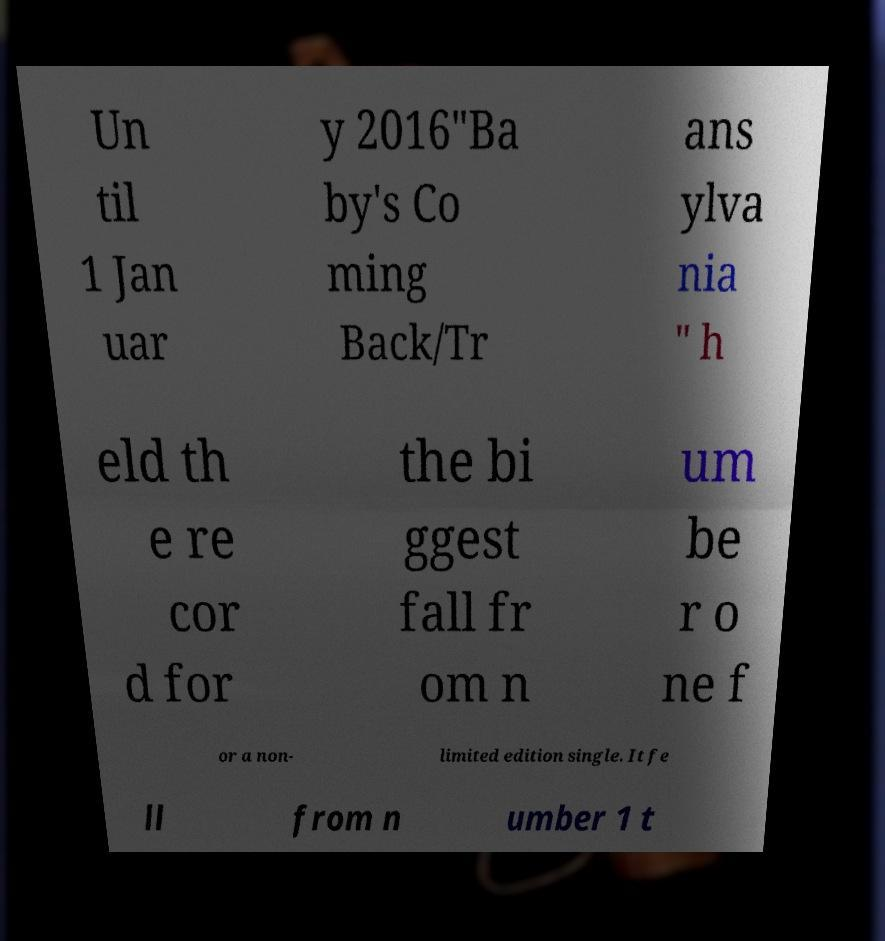Could you assist in decoding the text presented in this image and type it out clearly? Un til 1 Jan uar y 2016"Ba by's Co ming Back/Tr ans ylva nia " h eld th e re cor d for the bi ggest fall fr om n um be r o ne f or a non- limited edition single. It fe ll from n umber 1 t 